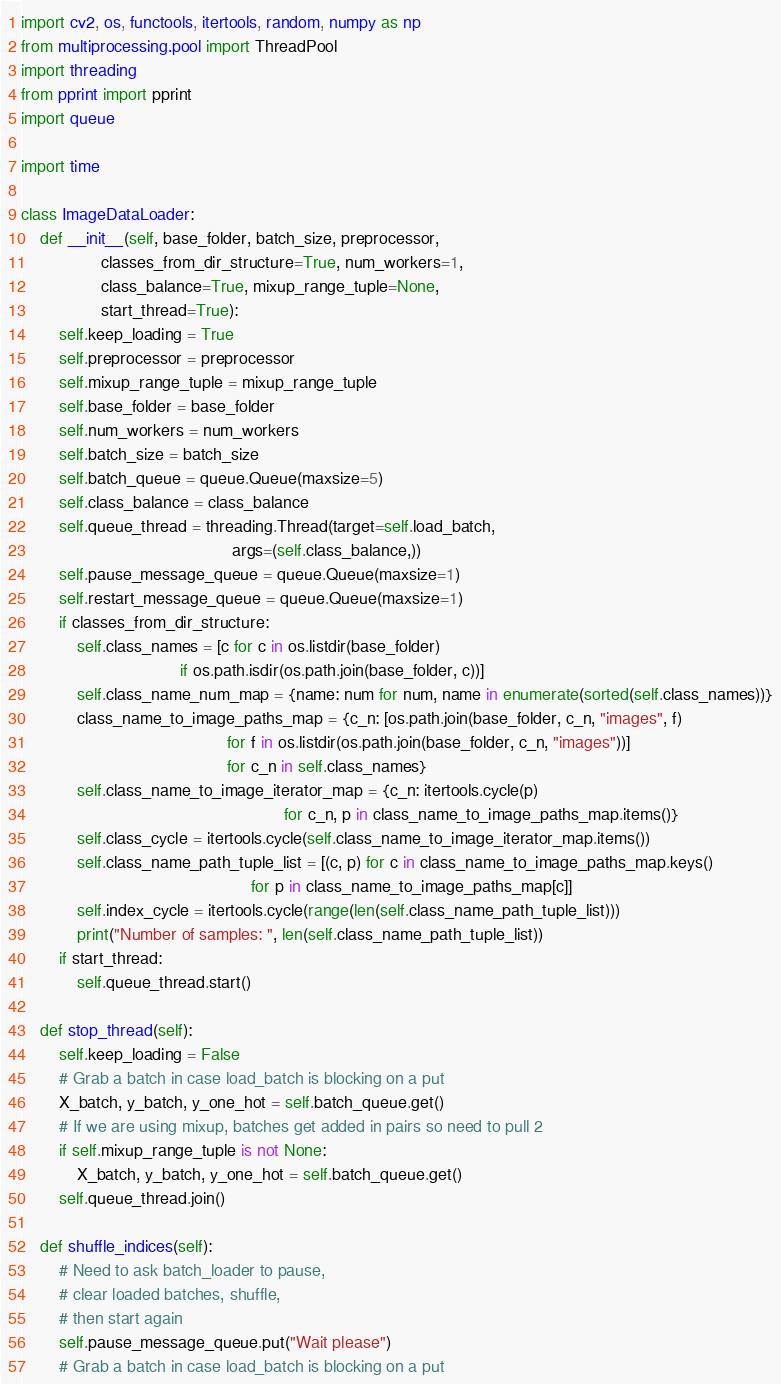Convert code to text. <code><loc_0><loc_0><loc_500><loc_500><_Python_>import cv2, os, functools, itertools, random, numpy as np
from multiprocessing.pool import ThreadPool
import threading
from pprint import pprint
import queue

import time

class ImageDataLoader:
    def __init__(self, base_folder, batch_size, preprocessor,
                 classes_from_dir_structure=True, num_workers=1,
                 class_balance=True, mixup_range_tuple=None, 
                 start_thread=True):
        self.keep_loading = True
        self.preprocessor = preprocessor
        self.mixup_range_tuple = mixup_range_tuple
        self.base_folder = base_folder
        self.num_workers = num_workers
        self.batch_size = batch_size
        self.batch_queue = queue.Queue(maxsize=5)
        self.class_balance = class_balance
        self.queue_thread = threading.Thread(target=self.load_batch,
                                             args=(self.class_balance,))
        self.pause_message_queue = queue.Queue(maxsize=1)
        self.restart_message_queue = queue.Queue(maxsize=1)
        if classes_from_dir_structure:
            self.class_names = [c for c in os.listdir(base_folder)
                                  if os.path.isdir(os.path.join(base_folder, c))]
            self.class_name_num_map = {name: num for num, name in enumerate(sorted(self.class_names))}
            class_name_to_image_paths_map = {c_n: [os.path.join(base_folder, c_n, "images", f)
                                            for f in os.listdir(os.path.join(base_folder, c_n, "images"))]
                                            for c_n in self.class_names}
            self.class_name_to_image_iterator_map = {c_n: itertools.cycle(p) 
                                                        for c_n, p in class_name_to_image_paths_map.items()}
            self.class_cycle = itertools.cycle(self.class_name_to_image_iterator_map.items())
            self.class_name_path_tuple_list = [(c, p) for c in class_name_to_image_paths_map.keys()
                                                 for p in class_name_to_image_paths_map[c]]
            self.index_cycle = itertools.cycle(range(len(self.class_name_path_tuple_list)))
            print("Number of samples: ", len(self.class_name_path_tuple_list))
        if start_thread:
            self.queue_thread.start()

    def stop_thread(self):
        self.keep_loading = False
        # Grab a batch in case load_batch is blocking on a put
        X_batch, y_batch, y_one_hot = self.batch_queue.get()
        # If we are using mixup, batches get added in pairs so need to pull 2
        if self.mixup_range_tuple is not None:
            X_batch, y_batch, y_one_hot = self.batch_queue.get()
        self.queue_thread.join()

    def shuffle_indices(self):
        # Need to ask batch_loader to pause, 
        # clear loaded batches, shuffle, 
        # then start again
        self.pause_message_queue.put("Wait please")
        # Grab a batch in case load_batch is blocking on a put</code> 